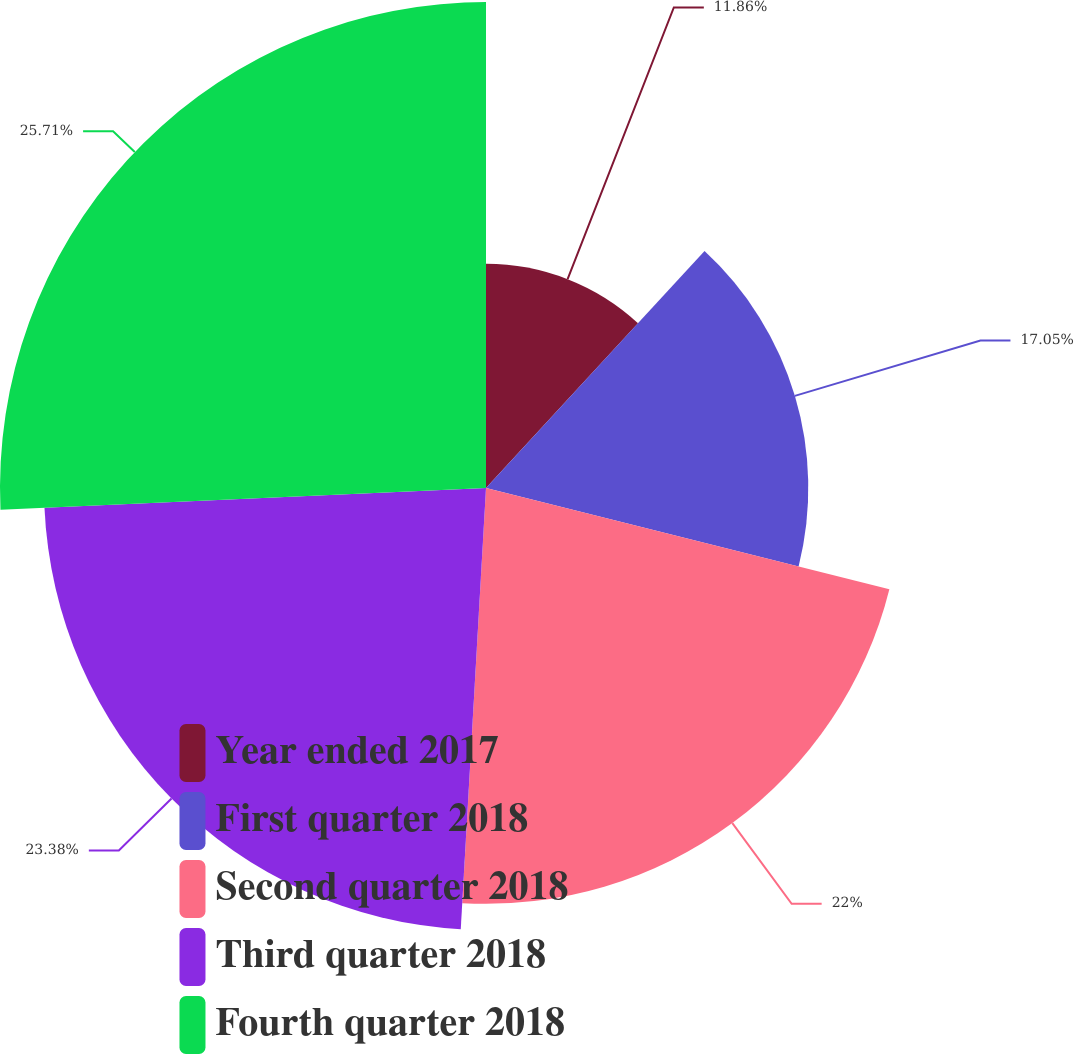Convert chart to OTSL. <chart><loc_0><loc_0><loc_500><loc_500><pie_chart><fcel>Year ended 2017<fcel>First quarter 2018<fcel>Second quarter 2018<fcel>Third quarter 2018<fcel>Fourth quarter 2018<nl><fcel>11.86%<fcel>17.05%<fcel>22.0%<fcel>23.38%<fcel>25.71%<nl></chart> 